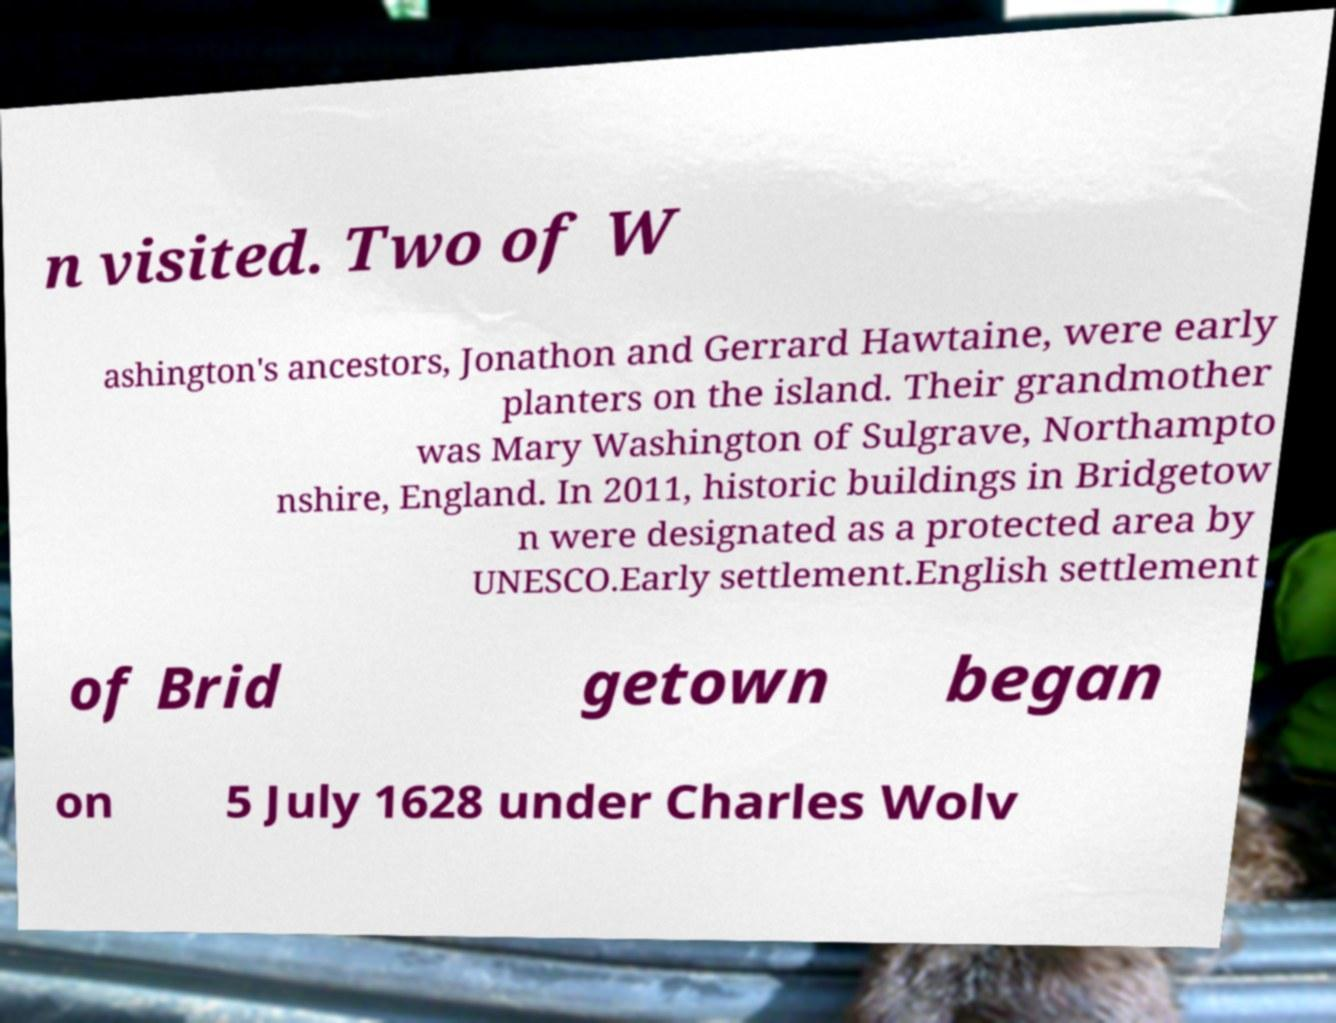Please identify and transcribe the text found in this image. n visited. Two of W ashington's ancestors, Jonathon and Gerrard Hawtaine, were early planters on the island. Their grandmother was Mary Washington of Sulgrave, Northampto nshire, England. In 2011, historic buildings in Bridgetow n were designated as a protected area by UNESCO.Early settlement.English settlement of Brid getown began on 5 July 1628 under Charles Wolv 